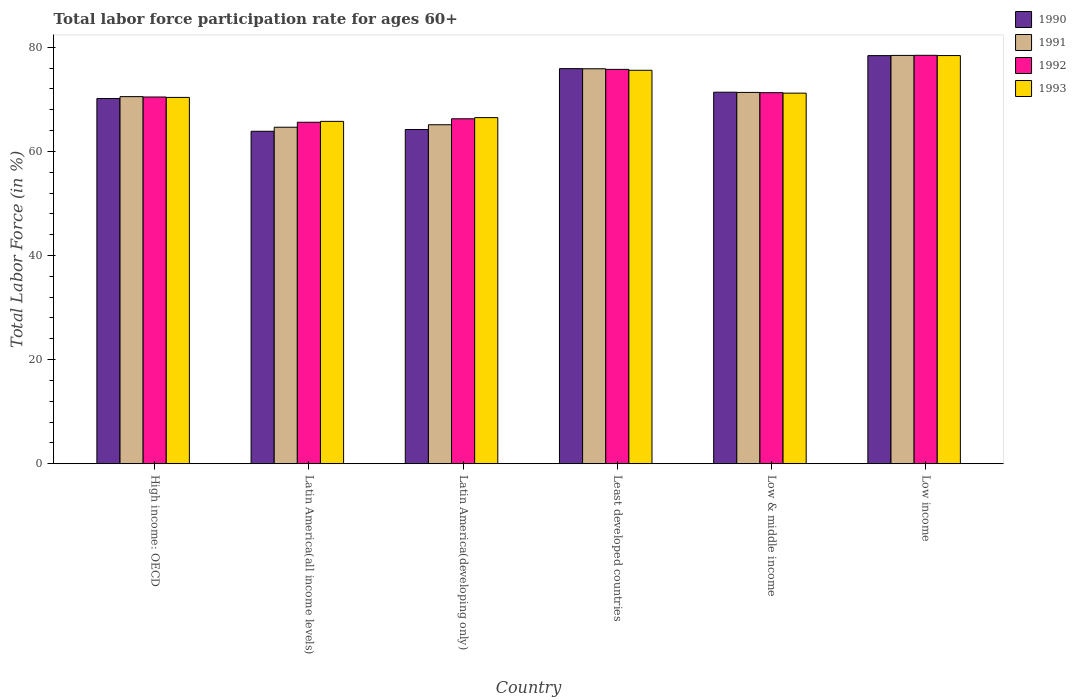How many different coloured bars are there?
Your answer should be compact. 4. How many groups of bars are there?
Your answer should be compact. 6. Are the number of bars per tick equal to the number of legend labels?
Offer a very short reply. Yes. Are the number of bars on each tick of the X-axis equal?
Your response must be concise. Yes. What is the label of the 4th group of bars from the left?
Offer a terse response. Least developed countries. What is the labor force participation rate in 1991 in Low & middle income?
Your response must be concise. 71.33. Across all countries, what is the maximum labor force participation rate in 1990?
Provide a succinct answer. 78.4. Across all countries, what is the minimum labor force participation rate in 1991?
Make the answer very short. 64.64. In which country was the labor force participation rate in 1991 maximum?
Give a very brief answer. Low income. In which country was the labor force participation rate in 1992 minimum?
Give a very brief answer. Latin America(all income levels). What is the total labor force participation rate in 1992 in the graph?
Give a very brief answer. 427.79. What is the difference between the labor force participation rate in 1990 in High income: OECD and that in Low income?
Offer a very short reply. -8.24. What is the difference between the labor force participation rate in 1993 in Latin America(all income levels) and the labor force participation rate in 1990 in High income: OECD?
Ensure brevity in your answer.  -4.39. What is the average labor force participation rate in 1991 per country?
Keep it short and to the point. 70.98. What is the difference between the labor force participation rate of/in 1992 and labor force participation rate of/in 1993 in Least developed countries?
Provide a succinct answer. 0.18. In how many countries, is the labor force participation rate in 1992 greater than 56 %?
Your answer should be very brief. 6. What is the ratio of the labor force participation rate in 1992 in Latin America(all income levels) to that in Low & middle income?
Offer a terse response. 0.92. Is the difference between the labor force participation rate in 1992 in High income: OECD and Least developed countries greater than the difference between the labor force participation rate in 1993 in High income: OECD and Least developed countries?
Provide a succinct answer. No. What is the difference between the highest and the second highest labor force participation rate in 1990?
Your answer should be compact. -2.5. What is the difference between the highest and the lowest labor force participation rate in 1993?
Provide a short and direct response. 12.64. Is the sum of the labor force participation rate in 1991 in Latin America(all income levels) and Low income greater than the maximum labor force participation rate in 1992 across all countries?
Provide a succinct answer. Yes. What does the 3rd bar from the left in Latin America(developing only) represents?
Your answer should be compact. 1992. What does the 1st bar from the right in Latin America(developing only) represents?
Your answer should be very brief. 1993. Is it the case that in every country, the sum of the labor force participation rate in 1993 and labor force participation rate in 1991 is greater than the labor force participation rate in 1992?
Provide a short and direct response. Yes. How many bars are there?
Give a very brief answer. 24. Are all the bars in the graph horizontal?
Keep it short and to the point. No. What is the difference between two consecutive major ticks on the Y-axis?
Give a very brief answer. 20. Does the graph contain grids?
Provide a succinct answer. No. What is the title of the graph?
Ensure brevity in your answer.  Total labor force participation rate for ages 60+. What is the Total Labor Force (in %) of 1990 in High income: OECD?
Give a very brief answer. 70.16. What is the Total Labor Force (in %) in 1991 in High income: OECD?
Your answer should be very brief. 70.52. What is the Total Labor Force (in %) of 1992 in High income: OECD?
Ensure brevity in your answer.  70.44. What is the Total Labor Force (in %) in 1993 in High income: OECD?
Your response must be concise. 70.37. What is the Total Labor Force (in %) in 1990 in Latin America(all income levels)?
Your answer should be very brief. 63.86. What is the Total Labor Force (in %) of 1991 in Latin America(all income levels)?
Offer a very short reply. 64.64. What is the Total Labor Force (in %) in 1992 in Latin America(all income levels)?
Offer a terse response. 65.59. What is the Total Labor Force (in %) in 1993 in Latin America(all income levels)?
Keep it short and to the point. 65.77. What is the Total Labor Force (in %) in 1990 in Latin America(developing only)?
Provide a short and direct response. 64.21. What is the Total Labor Force (in %) of 1991 in Latin America(developing only)?
Ensure brevity in your answer.  65.12. What is the Total Labor Force (in %) in 1992 in Latin America(developing only)?
Your answer should be very brief. 66.26. What is the Total Labor Force (in %) in 1993 in Latin America(developing only)?
Make the answer very short. 66.49. What is the Total Labor Force (in %) of 1990 in Least developed countries?
Provide a short and direct response. 75.89. What is the Total Labor Force (in %) in 1991 in Least developed countries?
Ensure brevity in your answer.  75.87. What is the Total Labor Force (in %) of 1992 in Least developed countries?
Give a very brief answer. 75.75. What is the Total Labor Force (in %) of 1993 in Least developed countries?
Your answer should be very brief. 75.58. What is the Total Labor Force (in %) of 1990 in Low & middle income?
Your response must be concise. 71.37. What is the Total Labor Force (in %) of 1991 in Low & middle income?
Make the answer very short. 71.33. What is the Total Labor Force (in %) in 1992 in Low & middle income?
Make the answer very short. 71.28. What is the Total Labor Force (in %) in 1993 in Low & middle income?
Provide a short and direct response. 71.19. What is the Total Labor Force (in %) in 1990 in Low income?
Your response must be concise. 78.4. What is the Total Labor Force (in %) in 1991 in Low income?
Your response must be concise. 78.44. What is the Total Labor Force (in %) in 1992 in Low income?
Offer a terse response. 78.46. What is the Total Labor Force (in %) in 1993 in Low income?
Offer a terse response. 78.41. Across all countries, what is the maximum Total Labor Force (in %) in 1990?
Offer a very short reply. 78.4. Across all countries, what is the maximum Total Labor Force (in %) in 1991?
Ensure brevity in your answer.  78.44. Across all countries, what is the maximum Total Labor Force (in %) in 1992?
Ensure brevity in your answer.  78.46. Across all countries, what is the maximum Total Labor Force (in %) of 1993?
Offer a very short reply. 78.41. Across all countries, what is the minimum Total Labor Force (in %) in 1990?
Keep it short and to the point. 63.86. Across all countries, what is the minimum Total Labor Force (in %) of 1991?
Your answer should be compact. 64.64. Across all countries, what is the minimum Total Labor Force (in %) in 1992?
Provide a short and direct response. 65.59. Across all countries, what is the minimum Total Labor Force (in %) of 1993?
Ensure brevity in your answer.  65.77. What is the total Total Labor Force (in %) of 1990 in the graph?
Give a very brief answer. 423.88. What is the total Total Labor Force (in %) of 1991 in the graph?
Offer a terse response. 425.91. What is the total Total Labor Force (in %) in 1992 in the graph?
Offer a terse response. 427.79. What is the total Total Labor Force (in %) in 1993 in the graph?
Give a very brief answer. 427.79. What is the difference between the Total Labor Force (in %) in 1990 in High income: OECD and that in Latin America(all income levels)?
Provide a succinct answer. 6.29. What is the difference between the Total Labor Force (in %) of 1991 in High income: OECD and that in Latin America(all income levels)?
Give a very brief answer. 5.88. What is the difference between the Total Labor Force (in %) in 1992 in High income: OECD and that in Latin America(all income levels)?
Ensure brevity in your answer.  4.85. What is the difference between the Total Labor Force (in %) in 1993 in High income: OECD and that in Latin America(all income levels)?
Your response must be concise. 4.6. What is the difference between the Total Labor Force (in %) in 1990 in High income: OECD and that in Latin America(developing only)?
Provide a succinct answer. 5.95. What is the difference between the Total Labor Force (in %) in 1991 in High income: OECD and that in Latin America(developing only)?
Provide a short and direct response. 5.4. What is the difference between the Total Labor Force (in %) in 1992 in High income: OECD and that in Latin America(developing only)?
Provide a short and direct response. 4.18. What is the difference between the Total Labor Force (in %) of 1993 in High income: OECD and that in Latin America(developing only)?
Ensure brevity in your answer.  3.88. What is the difference between the Total Labor Force (in %) in 1990 in High income: OECD and that in Least developed countries?
Your response must be concise. -5.74. What is the difference between the Total Labor Force (in %) in 1991 in High income: OECD and that in Least developed countries?
Make the answer very short. -5.35. What is the difference between the Total Labor Force (in %) of 1992 in High income: OECD and that in Least developed countries?
Offer a terse response. -5.31. What is the difference between the Total Labor Force (in %) of 1993 in High income: OECD and that in Least developed countries?
Provide a short and direct response. -5.21. What is the difference between the Total Labor Force (in %) of 1990 in High income: OECD and that in Low & middle income?
Provide a succinct answer. -1.21. What is the difference between the Total Labor Force (in %) in 1991 in High income: OECD and that in Low & middle income?
Keep it short and to the point. -0.81. What is the difference between the Total Labor Force (in %) in 1992 in High income: OECD and that in Low & middle income?
Your answer should be compact. -0.83. What is the difference between the Total Labor Force (in %) in 1993 in High income: OECD and that in Low & middle income?
Make the answer very short. -0.82. What is the difference between the Total Labor Force (in %) of 1990 in High income: OECD and that in Low income?
Make the answer very short. -8.24. What is the difference between the Total Labor Force (in %) of 1991 in High income: OECD and that in Low income?
Make the answer very short. -7.92. What is the difference between the Total Labor Force (in %) in 1992 in High income: OECD and that in Low income?
Provide a succinct answer. -8.01. What is the difference between the Total Labor Force (in %) of 1993 in High income: OECD and that in Low income?
Provide a short and direct response. -8.04. What is the difference between the Total Labor Force (in %) in 1990 in Latin America(all income levels) and that in Latin America(developing only)?
Provide a short and direct response. -0.34. What is the difference between the Total Labor Force (in %) in 1991 in Latin America(all income levels) and that in Latin America(developing only)?
Your answer should be very brief. -0.48. What is the difference between the Total Labor Force (in %) in 1992 in Latin America(all income levels) and that in Latin America(developing only)?
Your answer should be very brief. -0.67. What is the difference between the Total Labor Force (in %) of 1993 in Latin America(all income levels) and that in Latin America(developing only)?
Offer a very short reply. -0.72. What is the difference between the Total Labor Force (in %) in 1990 in Latin America(all income levels) and that in Least developed countries?
Offer a terse response. -12.03. What is the difference between the Total Labor Force (in %) in 1991 in Latin America(all income levels) and that in Least developed countries?
Your response must be concise. -11.23. What is the difference between the Total Labor Force (in %) of 1992 in Latin America(all income levels) and that in Least developed countries?
Make the answer very short. -10.16. What is the difference between the Total Labor Force (in %) of 1993 in Latin America(all income levels) and that in Least developed countries?
Offer a very short reply. -9.81. What is the difference between the Total Labor Force (in %) in 1990 in Latin America(all income levels) and that in Low & middle income?
Give a very brief answer. -7.5. What is the difference between the Total Labor Force (in %) of 1991 in Latin America(all income levels) and that in Low & middle income?
Provide a short and direct response. -6.69. What is the difference between the Total Labor Force (in %) of 1992 in Latin America(all income levels) and that in Low & middle income?
Your response must be concise. -5.68. What is the difference between the Total Labor Force (in %) in 1993 in Latin America(all income levels) and that in Low & middle income?
Make the answer very short. -5.42. What is the difference between the Total Labor Force (in %) of 1990 in Latin America(all income levels) and that in Low income?
Your answer should be compact. -14.53. What is the difference between the Total Labor Force (in %) of 1991 in Latin America(all income levels) and that in Low income?
Offer a terse response. -13.79. What is the difference between the Total Labor Force (in %) in 1992 in Latin America(all income levels) and that in Low income?
Your answer should be very brief. -12.86. What is the difference between the Total Labor Force (in %) of 1993 in Latin America(all income levels) and that in Low income?
Provide a short and direct response. -12.64. What is the difference between the Total Labor Force (in %) in 1990 in Latin America(developing only) and that in Least developed countries?
Offer a very short reply. -11.69. What is the difference between the Total Labor Force (in %) in 1991 in Latin America(developing only) and that in Least developed countries?
Offer a terse response. -10.75. What is the difference between the Total Labor Force (in %) in 1992 in Latin America(developing only) and that in Least developed countries?
Provide a short and direct response. -9.49. What is the difference between the Total Labor Force (in %) of 1993 in Latin America(developing only) and that in Least developed countries?
Your answer should be very brief. -9.09. What is the difference between the Total Labor Force (in %) in 1990 in Latin America(developing only) and that in Low & middle income?
Ensure brevity in your answer.  -7.16. What is the difference between the Total Labor Force (in %) in 1991 in Latin America(developing only) and that in Low & middle income?
Provide a short and direct response. -6.21. What is the difference between the Total Labor Force (in %) in 1992 in Latin America(developing only) and that in Low & middle income?
Your answer should be very brief. -5.01. What is the difference between the Total Labor Force (in %) in 1993 in Latin America(developing only) and that in Low & middle income?
Ensure brevity in your answer.  -4.7. What is the difference between the Total Labor Force (in %) in 1990 in Latin America(developing only) and that in Low income?
Provide a succinct answer. -14.19. What is the difference between the Total Labor Force (in %) in 1991 in Latin America(developing only) and that in Low income?
Ensure brevity in your answer.  -13.32. What is the difference between the Total Labor Force (in %) of 1992 in Latin America(developing only) and that in Low income?
Provide a short and direct response. -12.19. What is the difference between the Total Labor Force (in %) in 1993 in Latin America(developing only) and that in Low income?
Give a very brief answer. -11.92. What is the difference between the Total Labor Force (in %) of 1990 in Least developed countries and that in Low & middle income?
Ensure brevity in your answer.  4.53. What is the difference between the Total Labor Force (in %) of 1991 in Least developed countries and that in Low & middle income?
Ensure brevity in your answer.  4.54. What is the difference between the Total Labor Force (in %) in 1992 in Least developed countries and that in Low & middle income?
Ensure brevity in your answer.  4.48. What is the difference between the Total Labor Force (in %) of 1993 in Least developed countries and that in Low & middle income?
Offer a terse response. 4.39. What is the difference between the Total Labor Force (in %) in 1990 in Least developed countries and that in Low income?
Make the answer very short. -2.5. What is the difference between the Total Labor Force (in %) in 1991 in Least developed countries and that in Low income?
Ensure brevity in your answer.  -2.57. What is the difference between the Total Labor Force (in %) in 1992 in Least developed countries and that in Low income?
Ensure brevity in your answer.  -2.7. What is the difference between the Total Labor Force (in %) of 1993 in Least developed countries and that in Low income?
Provide a succinct answer. -2.83. What is the difference between the Total Labor Force (in %) of 1990 in Low & middle income and that in Low income?
Offer a terse response. -7.03. What is the difference between the Total Labor Force (in %) of 1991 in Low & middle income and that in Low income?
Your answer should be compact. -7.11. What is the difference between the Total Labor Force (in %) in 1992 in Low & middle income and that in Low income?
Your answer should be compact. -7.18. What is the difference between the Total Labor Force (in %) in 1993 in Low & middle income and that in Low income?
Keep it short and to the point. -7.22. What is the difference between the Total Labor Force (in %) in 1990 in High income: OECD and the Total Labor Force (in %) in 1991 in Latin America(all income levels)?
Offer a terse response. 5.51. What is the difference between the Total Labor Force (in %) of 1990 in High income: OECD and the Total Labor Force (in %) of 1992 in Latin America(all income levels)?
Provide a succinct answer. 4.56. What is the difference between the Total Labor Force (in %) in 1990 in High income: OECD and the Total Labor Force (in %) in 1993 in Latin America(all income levels)?
Make the answer very short. 4.39. What is the difference between the Total Labor Force (in %) in 1991 in High income: OECD and the Total Labor Force (in %) in 1992 in Latin America(all income levels)?
Offer a terse response. 4.92. What is the difference between the Total Labor Force (in %) of 1991 in High income: OECD and the Total Labor Force (in %) of 1993 in Latin America(all income levels)?
Provide a succinct answer. 4.75. What is the difference between the Total Labor Force (in %) of 1992 in High income: OECD and the Total Labor Force (in %) of 1993 in Latin America(all income levels)?
Ensure brevity in your answer.  4.68. What is the difference between the Total Labor Force (in %) of 1990 in High income: OECD and the Total Labor Force (in %) of 1991 in Latin America(developing only)?
Keep it short and to the point. 5.04. What is the difference between the Total Labor Force (in %) of 1990 in High income: OECD and the Total Labor Force (in %) of 1992 in Latin America(developing only)?
Offer a terse response. 3.89. What is the difference between the Total Labor Force (in %) of 1990 in High income: OECD and the Total Labor Force (in %) of 1993 in Latin America(developing only)?
Keep it short and to the point. 3.67. What is the difference between the Total Labor Force (in %) in 1991 in High income: OECD and the Total Labor Force (in %) in 1992 in Latin America(developing only)?
Offer a terse response. 4.25. What is the difference between the Total Labor Force (in %) in 1991 in High income: OECD and the Total Labor Force (in %) in 1993 in Latin America(developing only)?
Provide a short and direct response. 4.03. What is the difference between the Total Labor Force (in %) of 1992 in High income: OECD and the Total Labor Force (in %) of 1993 in Latin America(developing only)?
Give a very brief answer. 3.96. What is the difference between the Total Labor Force (in %) in 1990 in High income: OECD and the Total Labor Force (in %) in 1991 in Least developed countries?
Make the answer very short. -5.71. What is the difference between the Total Labor Force (in %) of 1990 in High income: OECD and the Total Labor Force (in %) of 1992 in Least developed countries?
Your answer should be very brief. -5.6. What is the difference between the Total Labor Force (in %) in 1990 in High income: OECD and the Total Labor Force (in %) in 1993 in Least developed countries?
Offer a terse response. -5.42. What is the difference between the Total Labor Force (in %) in 1991 in High income: OECD and the Total Labor Force (in %) in 1992 in Least developed countries?
Your response must be concise. -5.24. What is the difference between the Total Labor Force (in %) of 1991 in High income: OECD and the Total Labor Force (in %) of 1993 in Least developed countries?
Your answer should be very brief. -5.06. What is the difference between the Total Labor Force (in %) in 1992 in High income: OECD and the Total Labor Force (in %) in 1993 in Least developed countries?
Offer a very short reply. -5.13. What is the difference between the Total Labor Force (in %) in 1990 in High income: OECD and the Total Labor Force (in %) in 1991 in Low & middle income?
Keep it short and to the point. -1.17. What is the difference between the Total Labor Force (in %) of 1990 in High income: OECD and the Total Labor Force (in %) of 1992 in Low & middle income?
Your answer should be compact. -1.12. What is the difference between the Total Labor Force (in %) in 1990 in High income: OECD and the Total Labor Force (in %) in 1993 in Low & middle income?
Your answer should be compact. -1.03. What is the difference between the Total Labor Force (in %) in 1991 in High income: OECD and the Total Labor Force (in %) in 1992 in Low & middle income?
Ensure brevity in your answer.  -0.76. What is the difference between the Total Labor Force (in %) in 1991 in High income: OECD and the Total Labor Force (in %) in 1993 in Low & middle income?
Your answer should be compact. -0.67. What is the difference between the Total Labor Force (in %) of 1992 in High income: OECD and the Total Labor Force (in %) of 1993 in Low & middle income?
Your response must be concise. -0.74. What is the difference between the Total Labor Force (in %) of 1990 in High income: OECD and the Total Labor Force (in %) of 1991 in Low income?
Offer a very short reply. -8.28. What is the difference between the Total Labor Force (in %) of 1990 in High income: OECD and the Total Labor Force (in %) of 1992 in Low income?
Your answer should be compact. -8.3. What is the difference between the Total Labor Force (in %) in 1990 in High income: OECD and the Total Labor Force (in %) in 1993 in Low income?
Keep it short and to the point. -8.25. What is the difference between the Total Labor Force (in %) in 1991 in High income: OECD and the Total Labor Force (in %) in 1992 in Low income?
Provide a succinct answer. -7.94. What is the difference between the Total Labor Force (in %) of 1991 in High income: OECD and the Total Labor Force (in %) of 1993 in Low income?
Offer a very short reply. -7.89. What is the difference between the Total Labor Force (in %) of 1992 in High income: OECD and the Total Labor Force (in %) of 1993 in Low income?
Provide a short and direct response. -7.96. What is the difference between the Total Labor Force (in %) of 1990 in Latin America(all income levels) and the Total Labor Force (in %) of 1991 in Latin America(developing only)?
Your answer should be very brief. -1.25. What is the difference between the Total Labor Force (in %) in 1990 in Latin America(all income levels) and the Total Labor Force (in %) in 1992 in Latin America(developing only)?
Keep it short and to the point. -2.4. What is the difference between the Total Labor Force (in %) of 1990 in Latin America(all income levels) and the Total Labor Force (in %) of 1993 in Latin America(developing only)?
Ensure brevity in your answer.  -2.62. What is the difference between the Total Labor Force (in %) of 1991 in Latin America(all income levels) and the Total Labor Force (in %) of 1992 in Latin America(developing only)?
Provide a succinct answer. -1.62. What is the difference between the Total Labor Force (in %) of 1991 in Latin America(all income levels) and the Total Labor Force (in %) of 1993 in Latin America(developing only)?
Your answer should be compact. -1.84. What is the difference between the Total Labor Force (in %) of 1992 in Latin America(all income levels) and the Total Labor Force (in %) of 1993 in Latin America(developing only)?
Your answer should be very brief. -0.89. What is the difference between the Total Labor Force (in %) of 1990 in Latin America(all income levels) and the Total Labor Force (in %) of 1991 in Least developed countries?
Ensure brevity in your answer.  -12.01. What is the difference between the Total Labor Force (in %) in 1990 in Latin America(all income levels) and the Total Labor Force (in %) in 1992 in Least developed countries?
Offer a terse response. -11.89. What is the difference between the Total Labor Force (in %) in 1990 in Latin America(all income levels) and the Total Labor Force (in %) in 1993 in Least developed countries?
Give a very brief answer. -11.71. What is the difference between the Total Labor Force (in %) in 1991 in Latin America(all income levels) and the Total Labor Force (in %) in 1992 in Least developed countries?
Your response must be concise. -11.11. What is the difference between the Total Labor Force (in %) of 1991 in Latin America(all income levels) and the Total Labor Force (in %) of 1993 in Least developed countries?
Make the answer very short. -10.94. What is the difference between the Total Labor Force (in %) of 1992 in Latin America(all income levels) and the Total Labor Force (in %) of 1993 in Least developed countries?
Your answer should be compact. -9.98. What is the difference between the Total Labor Force (in %) in 1990 in Latin America(all income levels) and the Total Labor Force (in %) in 1991 in Low & middle income?
Your answer should be very brief. -7.46. What is the difference between the Total Labor Force (in %) in 1990 in Latin America(all income levels) and the Total Labor Force (in %) in 1992 in Low & middle income?
Provide a succinct answer. -7.41. What is the difference between the Total Labor Force (in %) of 1990 in Latin America(all income levels) and the Total Labor Force (in %) of 1993 in Low & middle income?
Offer a terse response. -7.32. What is the difference between the Total Labor Force (in %) of 1991 in Latin America(all income levels) and the Total Labor Force (in %) of 1992 in Low & middle income?
Give a very brief answer. -6.64. What is the difference between the Total Labor Force (in %) of 1991 in Latin America(all income levels) and the Total Labor Force (in %) of 1993 in Low & middle income?
Provide a succinct answer. -6.55. What is the difference between the Total Labor Force (in %) of 1992 in Latin America(all income levels) and the Total Labor Force (in %) of 1993 in Low & middle income?
Your answer should be very brief. -5.59. What is the difference between the Total Labor Force (in %) of 1990 in Latin America(all income levels) and the Total Labor Force (in %) of 1991 in Low income?
Your response must be concise. -14.57. What is the difference between the Total Labor Force (in %) of 1990 in Latin America(all income levels) and the Total Labor Force (in %) of 1992 in Low income?
Keep it short and to the point. -14.59. What is the difference between the Total Labor Force (in %) of 1990 in Latin America(all income levels) and the Total Labor Force (in %) of 1993 in Low income?
Your response must be concise. -14.54. What is the difference between the Total Labor Force (in %) of 1991 in Latin America(all income levels) and the Total Labor Force (in %) of 1992 in Low income?
Ensure brevity in your answer.  -13.82. What is the difference between the Total Labor Force (in %) in 1991 in Latin America(all income levels) and the Total Labor Force (in %) in 1993 in Low income?
Your response must be concise. -13.77. What is the difference between the Total Labor Force (in %) of 1992 in Latin America(all income levels) and the Total Labor Force (in %) of 1993 in Low income?
Ensure brevity in your answer.  -12.81. What is the difference between the Total Labor Force (in %) of 1990 in Latin America(developing only) and the Total Labor Force (in %) of 1991 in Least developed countries?
Provide a succinct answer. -11.66. What is the difference between the Total Labor Force (in %) in 1990 in Latin America(developing only) and the Total Labor Force (in %) in 1992 in Least developed countries?
Keep it short and to the point. -11.55. What is the difference between the Total Labor Force (in %) of 1990 in Latin America(developing only) and the Total Labor Force (in %) of 1993 in Least developed countries?
Your answer should be compact. -11.37. What is the difference between the Total Labor Force (in %) in 1991 in Latin America(developing only) and the Total Labor Force (in %) in 1992 in Least developed countries?
Your response must be concise. -10.64. What is the difference between the Total Labor Force (in %) in 1991 in Latin America(developing only) and the Total Labor Force (in %) in 1993 in Least developed countries?
Make the answer very short. -10.46. What is the difference between the Total Labor Force (in %) in 1992 in Latin America(developing only) and the Total Labor Force (in %) in 1993 in Least developed countries?
Offer a very short reply. -9.31. What is the difference between the Total Labor Force (in %) of 1990 in Latin America(developing only) and the Total Labor Force (in %) of 1991 in Low & middle income?
Your response must be concise. -7.12. What is the difference between the Total Labor Force (in %) of 1990 in Latin America(developing only) and the Total Labor Force (in %) of 1992 in Low & middle income?
Your response must be concise. -7.07. What is the difference between the Total Labor Force (in %) in 1990 in Latin America(developing only) and the Total Labor Force (in %) in 1993 in Low & middle income?
Keep it short and to the point. -6.98. What is the difference between the Total Labor Force (in %) of 1991 in Latin America(developing only) and the Total Labor Force (in %) of 1992 in Low & middle income?
Provide a short and direct response. -6.16. What is the difference between the Total Labor Force (in %) in 1991 in Latin America(developing only) and the Total Labor Force (in %) in 1993 in Low & middle income?
Offer a very short reply. -6.07. What is the difference between the Total Labor Force (in %) in 1992 in Latin America(developing only) and the Total Labor Force (in %) in 1993 in Low & middle income?
Make the answer very short. -4.92. What is the difference between the Total Labor Force (in %) of 1990 in Latin America(developing only) and the Total Labor Force (in %) of 1991 in Low income?
Offer a very short reply. -14.23. What is the difference between the Total Labor Force (in %) of 1990 in Latin America(developing only) and the Total Labor Force (in %) of 1992 in Low income?
Your response must be concise. -14.25. What is the difference between the Total Labor Force (in %) of 1990 in Latin America(developing only) and the Total Labor Force (in %) of 1993 in Low income?
Ensure brevity in your answer.  -14.2. What is the difference between the Total Labor Force (in %) of 1991 in Latin America(developing only) and the Total Labor Force (in %) of 1992 in Low income?
Offer a terse response. -13.34. What is the difference between the Total Labor Force (in %) in 1991 in Latin America(developing only) and the Total Labor Force (in %) in 1993 in Low income?
Provide a succinct answer. -13.29. What is the difference between the Total Labor Force (in %) of 1992 in Latin America(developing only) and the Total Labor Force (in %) of 1993 in Low income?
Provide a short and direct response. -12.14. What is the difference between the Total Labor Force (in %) in 1990 in Least developed countries and the Total Labor Force (in %) in 1991 in Low & middle income?
Your response must be concise. 4.57. What is the difference between the Total Labor Force (in %) in 1990 in Least developed countries and the Total Labor Force (in %) in 1992 in Low & middle income?
Keep it short and to the point. 4.62. What is the difference between the Total Labor Force (in %) in 1990 in Least developed countries and the Total Labor Force (in %) in 1993 in Low & middle income?
Your response must be concise. 4.71. What is the difference between the Total Labor Force (in %) of 1991 in Least developed countries and the Total Labor Force (in %) of 1992 in Low & middle income?
Your answer should be compact. 4.59. What is the difference between the Total Labor Force (in %) of 1991 in Least developed countries and the Total Labor Force (in %) of 1993 in Low & middle income?
Ensure brevity in your answer.  4.68. What is the difference between the Total Labor Force (in %) of 1992 in Least developed countries and the Total Labor Force (in %) of 1993 in Low & middle income?
Offer a terse response. 4.57. What is the difference between the Total Labor Force (in %) of 1990 in Least developed countries and the Total Labor Force (in %) of 1991 in Low income?
Make the answer very short. -2.54. What is the difference between the Total Labor Force (in %) in 1990 in Least developed countries and the Total Labor Force (in %) in 1992 in Low income?
Ensure brevity in your answer.  -2.56. What is the difference between the Total Labor Force (in %) in 1990 in Least developed countries and the Total Labor Force (in %) in 1993 in Low income?
Provide a short and direct response. -2.51. What is the difference between the Total Labor Force (in %) in 1991 in Least developed countries and the Total Labor Force (in %) in 1992 in Low income?
Offer a very short reply. -2.59. What is the difference between the Total Labor Force (in %) in 1991 in Least developed countries and the Total Labor Force (in %) in 1993 in Low income?
Give a very brief answer. -2.54. What is the difference between the Total Labor Force (in %) in 1992 in Least developed countries and the Total Labor Force (in %) in 1993 in Low income?
Your response must be concise. -2.65. What is the difference between the Total Labor Force (in %) of 1990 in Low & middle income and the Total Labor Force (in %) of 1991 in Low income?
Make the answer very short. -7.07. What is the difference between the Total Labor Force (in %) of 1990 in Low & middle income and the Total Labor Force (in %) of 1992 in Low income?
Provide a short and direct response. -7.09. What is the difference between the Total Labor Force (in %) in 1990 in Low & middle income and the Total Labor Force (in %) in 1993 in Low income?
Offer a very short reply. -7.04. What is the difference between the Total Labor Force (in %) of 1991 in Low & middle income and the Total Labor Force (in %) of 1992 in Low income?
Ensure brevity in your answer.  -7.13. What is the difference between the Total Labor Force (in %) of 1991 in Low & middle income and the Total Labor Force (in %) of 1993 in Low income?
Provide a short and direct response. -7.08. What is the difference between the Total Labor Force (in %) of 1992 in Low & middle income and the Total Labor Force (in %) of 1993 in Low income?
Your answer should be very brief. -7.13. What is the average Total Labor Force (in %) of 1990 per country?
Offer a terse response. 70.65. What is the average Total Labor Force (in %) of 1991 per country?
Your answer should be compact. 70.98. What is the average Total Labor Force (in %) in 1992 per country?
Your answer should be very brief. 71.3. What is the average Total Labor Force (in %) of 1993 per country?
Provide a short and direct response. 71.3. What is the difference between the Total Labor Force (in %) in 1990 and Total Labor Force (in %) in 1991 in High income: OECD?
Your response must be concise. -0.36. What is the difference between the Total Labor Force (in %) in 1990 and Total Labor Force (in %) in 1992 in High income: OECD?
Give a very brief answer. -0.29. What is the difference between the Total Labor Force (in %) of 1990 and Total Labor Force (in %) of 1993 in High income: OECD?
Your response must be concise. -0.21. What is the difference between the Total Labor Force (in %) of 1991 and Total Labor Force (in %) of 1992 in High income: OECD?
Offer a very short reply. 0.07. What is the difference between the Total Labor Force (in %) in 1991 and Total Labor Force (in %) in 1993 in High income: OECD?
Provide a succinct answer. 0.15. What is the difference between the Total Labor Force (in %) in 1992 and Total Labor Force (in %) in 1993 in High income: OECD?
Make the answer very short. 0.08. What is the difference between the Total Labor Force (in %) in 1990 and Total Labor Force (in %) in 1991 in Latin America(all income levels)?
Make the answer very short. -0.78. What is the difference between the Total Labor Force (in %) in 1990 and Total Labor Force (in %) in 1992 in Latin America(all income levels)?
Ensure brevity in your answer.  -1.73. What is the difference between the Total Labor Force (in %) in 1990 and Total Labor Force (in %) in 1993 in Latin America(all income levels)?
Your response must be concise. -1.9. What is the difference between the Total Labor Force (in %) in 1991 and Total Labor Force (in %) in 1992 in Latin America(all income levels)?
Ensure brevity in your answer.  -0.95. What is the difference between the Total Labor Force (in %) of 1991 and Total Labor Force (in %) of 1993 in Latin America(all income levels)?
Your answer should be compact. -1.12. What is the difference between the Total Labor Force (in %) in 1992 and Total Labor Force (in %) in 1993 in Latin America(all income levels)?
Provide a succinct answer. -0.17. What is the difference between the Total Labor Force (in %) of 1990 and Total Labor Force (in %) of 1991 in Latin America(developing only)?
Your answer should be compact. -0.91. What is the difference between the Total Labor Force (in %) of 1990 and Total Labor Force (in %) of 1992 in Latin America(developing only)?
Your answer should be very brief. -2.06. What is the difference between the Total Labor Force (in %) of 1990 and Total Labor Force (in %) of 1993 in Latin America(developing only)?
Your response must be concise. -2.28. What is the difference between the Total Labor Force (in %) of 1991 and Total Labor Force (in %) of 1992 in Latin America(developing only)?
Your response must be concise. -1.15. What is the difference between the Total Labor Force (in %) in 1991 and Total Labor Force (in %) in 1993 in Latin America(developing only)?
Offer a terse response. -1.37. What is the difference between the Total Labor Force (in %) in 1992 and Total Labor Force (in %) in 1993 in Latin America(developing only)?
Your answer should be compact. -0.22. What is the difference between the Total Labor Force (in %) of 1990 and Total Labor Force (in %) of 1991 in Least developed countries?
Keep it short and to the point. 0.03. What is the difference between the Total Labor Force (in %) of 1990 and Total Labor Force (in %) of 1992 in Least developed countries?
Offer a terse response. 0.14. What is the difference between the Total Labor Force (in %) of 1990 and Total Labor Force (in %) of 1993 in Least developed countries?
Offer a terse response. 0.32. What is the difference between the Total Labor Force (in %) of 1991 and Total Labor Force (in %) of 1992 in Least developed countries?
Ensure brevity in your answer.  0.11. What is the difference between the Total Labor Force (in %) in 1991 and Total Labor Force (in %) in 1993 in Least developed countries?
Provide a short and direct response. 0.29. What is the difference between the Total Labor Force (in %) of 1992 and Total Labor Force (in %) of 1993 in Least developed countries?
Provide a succinct answer. 0.18. What is the difference between the Total Labor Force (in %) in 1990 and Total Labor Force (in %) in 1991 in Low & middle income?
Make the answer very short. 0.04. What is the difference between the Total Labor Force (in %) of 1990 and Total Labor Force (in %) of 1992 in Low & middle income?
Provide a succinct answer. 0.09. What is the difference between the Total Labor Force (in %) in 1990 and Total Labor Force (in %) in 1993 in Low & middle income?
Offer a terse response. 0.18. What is the difference between the Total Labor Force (in %) in 1991 and Total Labor Force (in %) in 1992 in Low & middle income?
Your answer should be compact. 0.05. What is the difference between the Total Labor Force (in %) of 1991 and Total Labor Force (in %) of 1993 in Low & middle income?
Provide a short and direct response. 0.14. What is the difference between the Total Labor Force (in %) of 1992 and Total Labor Force (in %) of 1993 in Low & middle income?
Offer a very short reply. 0.09. What is the difference between the Total Labor Force (in %) of 1990 and Total Labor Force (in %) of 1991 in Low income?
Your response must be concise. -0.04. What is the difference between the Total Labor Force (in %) in 1990 and Total Labor Force (in %) in 1992 in Low income?
Give a very brief answer. -0.06. What is the difference between the Total Labor Force (in %) of 1990 and Total Labor Force (in %) of 1993 in Low income?
Keep it short and to the point. -0.01. What is the difference between the Total Labor Force (in %) in 1991 and Total Labor Force (in %) in 1992 in Low income?
Your answer should be very brief. -0.02. What is the difference between the Total Labor Force (in %) of 1991 and Total Labor Force (in %) of 1993 in Low income?
Provide a succinct answer. 0.03. What is the difference between the Total Labor Force (in %) of 1992 and Total Labor Force (in %) of 1993 in Low income?
Your answer should be very brief. 0.05. What is the ratio of the Total Labor Force (in %) in 1990 in High income: OECD to that in Latin America(all income levels)?
Offer a very short reply. 1.1. What is the ratio of the Total Labor Force (in %) of 1992 in High income: OECD to that in Latin America(all income levels)?
Offer a very short reply. 1.07. What is the ratio of the Total Labor Force (in %) of 1993 in High income: OECD to that in Latin America(all income levels)?
Give a very brief answer. 1.07. What is the ratio of the Total Labor Force (in %) in 1990 in High income: OECD to that in Latin America(developing only)?
Provide a succinct answer. 1.09. What is the ratio of the Total Labor Force (in %) in 1991 in High income: OECD to that in Latin America(developing only)?
Offer a very short reply. 1.08. What is the ratio of the Total Labor Force (in %) in 1992 in High income: OECD to that in Latin America(developing only)?
Your answer should be compact. 1.06. What is the ratio of the Total Labor Force (in %) in 1993 in High income: OECD to that in Latin America(developing only)?
Give a very brief answer. 1.06. What is the ratio of the Total Labor Force (in %) in 1990 in High income: OECD to that in Least developed countries?
Offer a terse response. 0.92. What is the ratio of the Total Labor Force (in %) of 1991 in High income: OECD to that in Least developed countries?
Your answer should be compact. 0.93. What is the ratio of the Total Labor Force (in %) of 1992 in High income: OECD to that in Least developed countries?
Offer a terse response. 0.93. What is the ratio of the Total Labor Force (in %) of 1993 in High income: OECD to that in Least developed countries?
Ensure brevity in your answer.  0.93. What is the ratio of the Total Labor Force (in %) in 1990 in High income: OECD to that in Low & middle income?
Your answer should be compact. 0.98. What is the ratio of the Total Labor Force (in %) in 1991 in High income: OECD to that in Low & middle income?
Keep it short and to the point. 0.99. What is the ratio of the Total Labor Force (in %) in 1992 in High income: OECD to that in Low & middle income?
Your response must be concise. 0.99. What is the ratio of the Total Labor Force (in %) in 1990 in High income: OECD to that in Low income?
Offer a terse response. 0.89. What is the ratio of the Total Labor Force (in %) in 1991 in High income: OECD to that in Low income?
Ensure brevity in your answer.  0.9. What is the ratio of the Total Labor Force (in %) of 1992 in High income: OECD to that in Low income?
Make the answer very short. 0.9. What is the ratio of the Total Labor Force (in %) in 1993 in High income: OECD to that in Low income?
Your answer should be very brief. 0.9. What is the ratio of the Total Labor Force (in %) in 1993 in Latin America(all income levels) to that in Latin America(developing only)?
Offer a terse response. 0.99. What is the ratio of the Total Labor Force (in %) of 1990 in Latin America(all income levels) to that in Least developed countries?
Your response must be concise. 0.84. What is the ratio of the Total Labor Force (in %) of 1991 in Latin America(all income levels) to that in Least developed countries?
Provide a short and direct response. 0.85. What is the ratio of the Total Labor Force (in %) of 1992 in Latin America(all income levels) to that in Least developed countries?
Offer a very short reply. 0.87. What is the ratio of the Total Labor Force (in %) of 1993 in Latin America(all income levels) to that in Least developed countries?
Give a very brief answer. 0.87. What is the ratio of the Total Labor Force (in %) of 1990 in Latin America(all income levels) to that in Low & middle income?
Your response must be concise. 0.89. What is the ratio of the Total Labor Force (in %) of 1991 in Latin America(all income levels) to that in Low & middle income?
Offer a very short reply. 0.91. What is the ratio of the Total Labor Force (in %) in 1992 in Latin America(all income levels) to that in Low & middle income?
Ensure brevity in your answer.  0.92. What is the ratio of the Total Labor Force (in %) in 1993 in Latin America(all income levels) to that in Low & middle income?
Keep it short and to the point. 0.92. What is the ratio of the Total Labor Force (in %) in 1990 in Latin America(all income levels) to that in Low income?
Give a very brief answer. 0.81. What is the ratio of the Total Labor Force (in %) in 1991 in Latin America(all income levels) to that in Low income?
Offer a very short reply. 0.82. What is the ratio of the Total Labor Force (in %) in 1992 in Latin America(all income levels) to that in Low income?
Offer a terse response. 0.84. What is the ratio of the Total Labor Force (in %) of 1993 in Latin America(all income levels) to that in Low income?
Offer a very short reply. 0.84. What is the ratio of the Total Labor Force (in %) in 1990 in Latin America(developing only) to that in Least developed countries?
Give a very brief answer. 0.85. What is the ratio of the Total Labor Force (in %) in 1991 in Latin America(developing only) to that in Least developed countries?
Make the answer very short. 0.86. What is the ratio of the Total Labor Force (in %) in 1992 in Latin America(developing only) to that in Least developed countries?
Offer a very short reply. 0.87. What is the ratio of the Total Labor Force (in %) in 1993 in Latin America(developing only) to that in Least developed countries?
Provide a short and direct response. 0.88. What is the ratio of the Total Labor Force (in %) in 1990 in Latin America(developing only) to that in Low & middle income?
Provide a succinct answer. 0.9. What is the ratio of the Total Labor Force (in %) of 1992 in Latin America(developing only) to that in Low & middle income?
Keep it short and to the point. 0.93. What is the ratio of the Total Labor Force (in %) of 1993 in Latin America(developing only) to that in Low & middle income?
Offer a very short reply. 0.93. What is the ratio of the Total Labor Force (in %) of 1990 in Latin America(developing only) to that in Low income?
Offer a very short reply. 0.82. What is the ratio of the Total Labor Force (in %) of 1991 in Latin America(developing only) to that in Low income?
Make the answer very short. 0.83. What is the ratio of the Total Labor Force (in %) of 1992 in Latin America(developing only) to that in Low income?
Ensure brevity in your answer.  0.84. What is the ratio of the Total Labor Force (in %) in 1993 in Latin America(developing only) to that in Low income?
Offer a terse response. 0.85. What is the ratio of the Total Labor Force (in %) in 1990 in Least developed countries to that in Low & middle income?
Ensure brevity in your answer.  1.06. What is the ratio of the Total Labor Force (in %) in 1991 in Least developed countries to that in Low & middle income?
Offer a very short reply. 1.06. What is the ratio of the Total Labor Force (in %) of 1992 in Least developed countries to that in Low & middle income?
Make the answer very short. 1.06. What is the ratio of the Total Labor Force (in %) of 1993 in Least developed countries to that in Low & middle income?
Keep it short and to the point. 1.06. What is the ratio of the Total Labor Force (in %) in 1990 in Least developed countries to that in Low income?
Your response must be concise. 0.97. What is the ratio of the Total Labor Force (in %) of 1991 in Least developed countries to that in Low income?
Keep it short and to the point. 0.97. What is the ratio of the Total Labor Force (in %) of 1992 in Least developed countries to that in Low income?
Your answer should be very brief. 0.97. What is the ratio of the Total Labor Force (in %) of 1993 in Least developed countries to that in Low income?
Provide a succinct answer. 0.96. What is the ratio of the Total Labor Force (in %) of 1990 in Low & middle income to that in Low income?
Provide a short and direct response. 0.91. What is the ratio of the Total Labor Force (in %) in 1991 in Low & middle income to that in Low income?
Give a very brief answer. 0.91. What is the ratio of the Total Labor Force (in %) in 1992 in Low & middle income to that in Low income?
Provide a short and direct response. 0.91. What is the ratio of the Total Labor Force (in %) of 1993 in Low & middle income to that in Low income?
Your answer should be very brief. 0.91. What is the difference between the highest and the second highest Total Labor Force (in %) of 1990?
Your answer should be compact. 2.5. What is the difference between the highest and the second highest Total Labor Force (in %) of 1991?
Give a very brief answer. 2.57. What is the difference between the highest and the second highest Total Labor Force (in %) in 1992?
Offer a terse response. 2.7. What is the difference between the highest and the second highest Total Labor Force (in %) of 1993?
Provide a short and direct response. 2.83. What is the difference between the highest and the lowest Total Labor Force (in %) in 1990?
Offer a terse response. 14.53. What is the difference between the highest and the lowest Total Labor Force (in %) in 1991?
Your response must be concise. 13.79. What is the difference between the highest and the lowest Total Labor Force (in %) of 1992?
Keep it short and to the point. 12.86. What is the difference between the highest and the lowest Total Labor Force (in %) of 1993?
Make the answer very short. 12.64. 